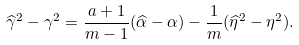<formula> <loc_0><loc_0><loc_500><loc_500>\widehat { \gamma } ^ { 2 } - \gamma ^ { 2 } = \frac { a + 1 } { m - 1 } ( \widehat { \alpha } - \alpha ) - \frac { 1 } { m } ( \widehat { \eta } ^ { 2 } - \eta ^ { 2 } ) .</formula> 